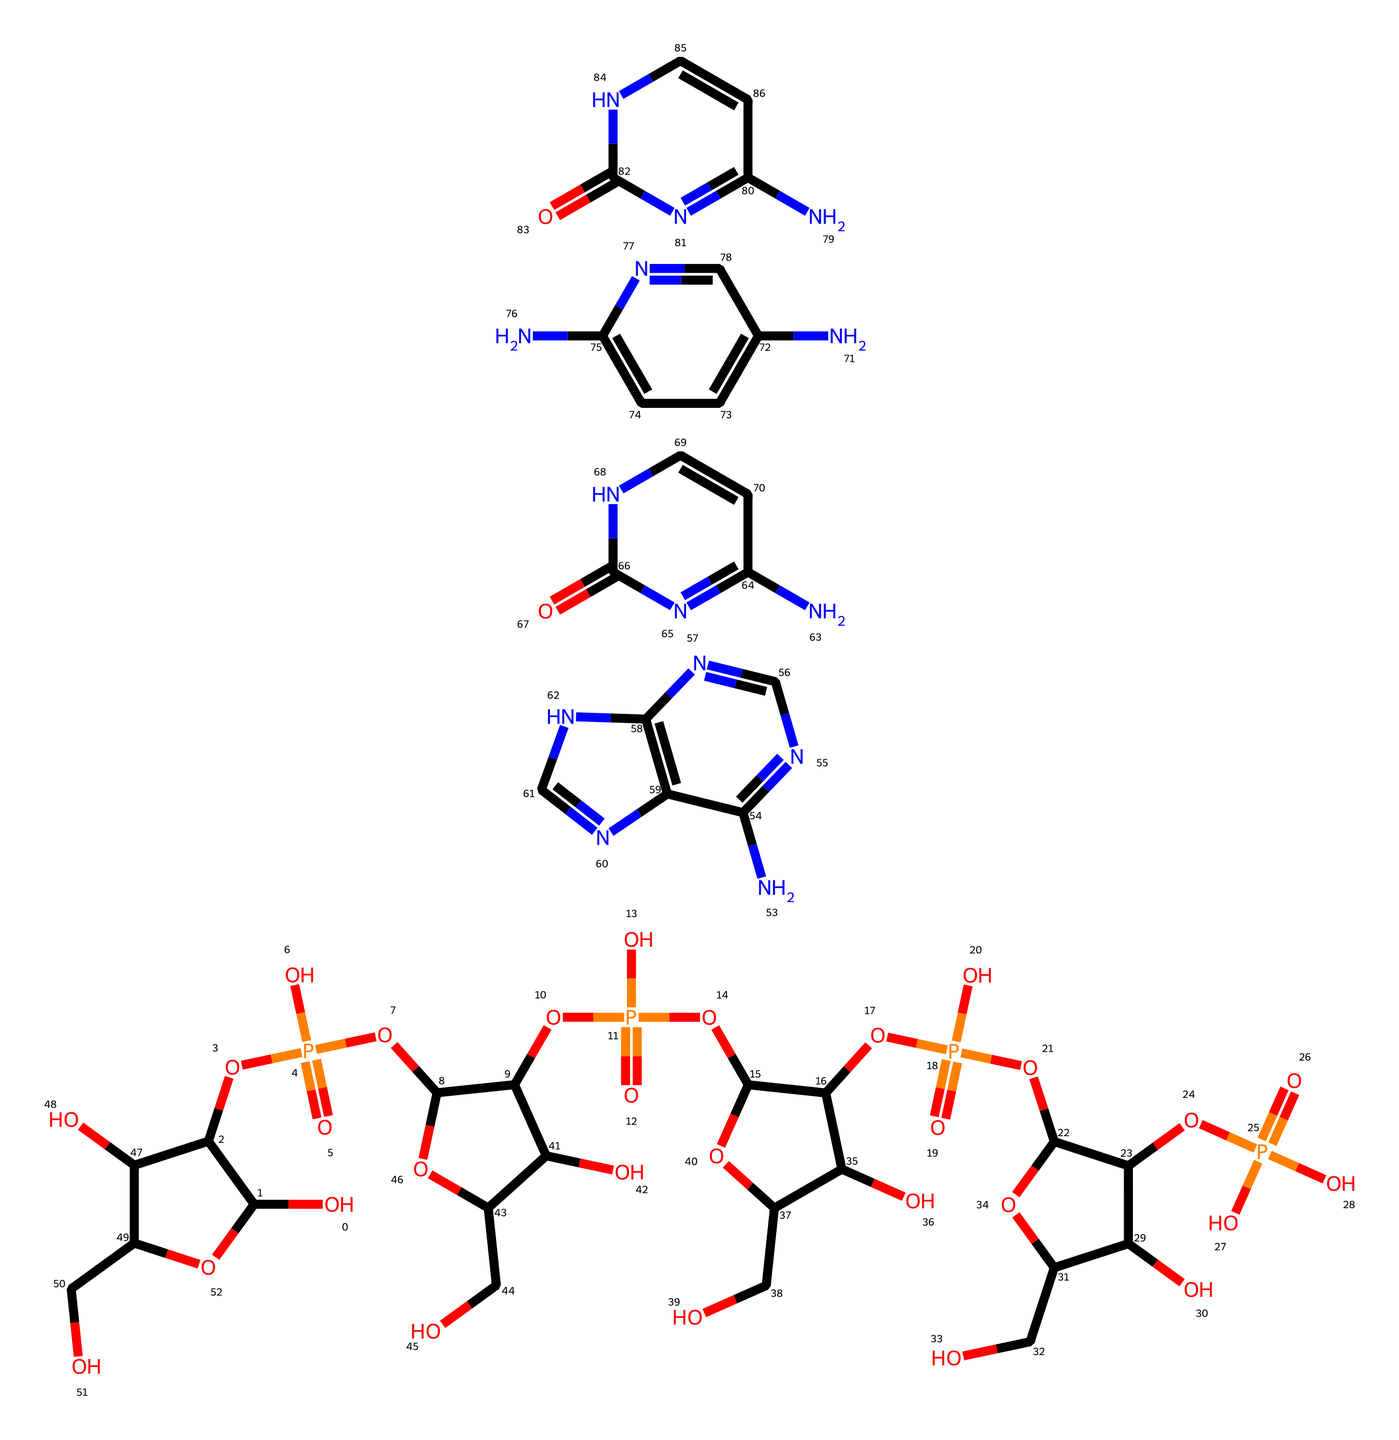How many nucleotides are present in this SMILES representation? The SMILES indicates multiple nucleotide structures based on the repetition of specific backbone components, which are linked by phosphate groups. Counting the distinct sugar and base components, we find there are four distinct nucleotides used in the structure.
Answer: four What type of sugar is represented in the nucleotides? The presence of the "C(O)" sequences and "OC" in the SMILES indicates the structure resembles ribose, which is a five-carbon sugar typically found in RNA.
Answer: ribose How many nitrogenous bases are included? By examining the different nitrogen-containing ring structures within the SMILES, there are four distinct bases that can be identified as purines and pyrimidines, considering they have the pattern of nitrogen atoms relative to carbon.
Answer: four What type of bond links the nucleotides together? The "O[P](=O)(O)" part of the SMILES notation indicates the presence of phosphate groups, which form phosphodiester bonds connecting the sugar moieties of adjacent nucleotides, linking them together chemically.
Answer: phosphodiester Which base pairs are likely formed in this DNA structure? Based on standard base-pairing rules in DNA (adenine with thymine, and guanine with cytosine), the presence of nitrogenous bases in the SMILES representation implies that complementary pairs will form accordingly when considering the bases.
Answer: adenine-thymine, guanine-cytosine What is the overall charge of the DNA molecule represented? Considering the presence of phosphates that typically carry a negative charge in biological molecules, the overall charge of the DNA fragment would be negative due to the abundance of these phosphate groups along the backbone.
Answer: negative What is the role of the phosphate groups in this structure? Phosphate groups are crucial for the formation of the backbone of DNA, and they participate in providing structural integrity and energy necessary for the polymerization of nucleotides during DNA replication and synthesis.
Answer: backbone structural integrity 